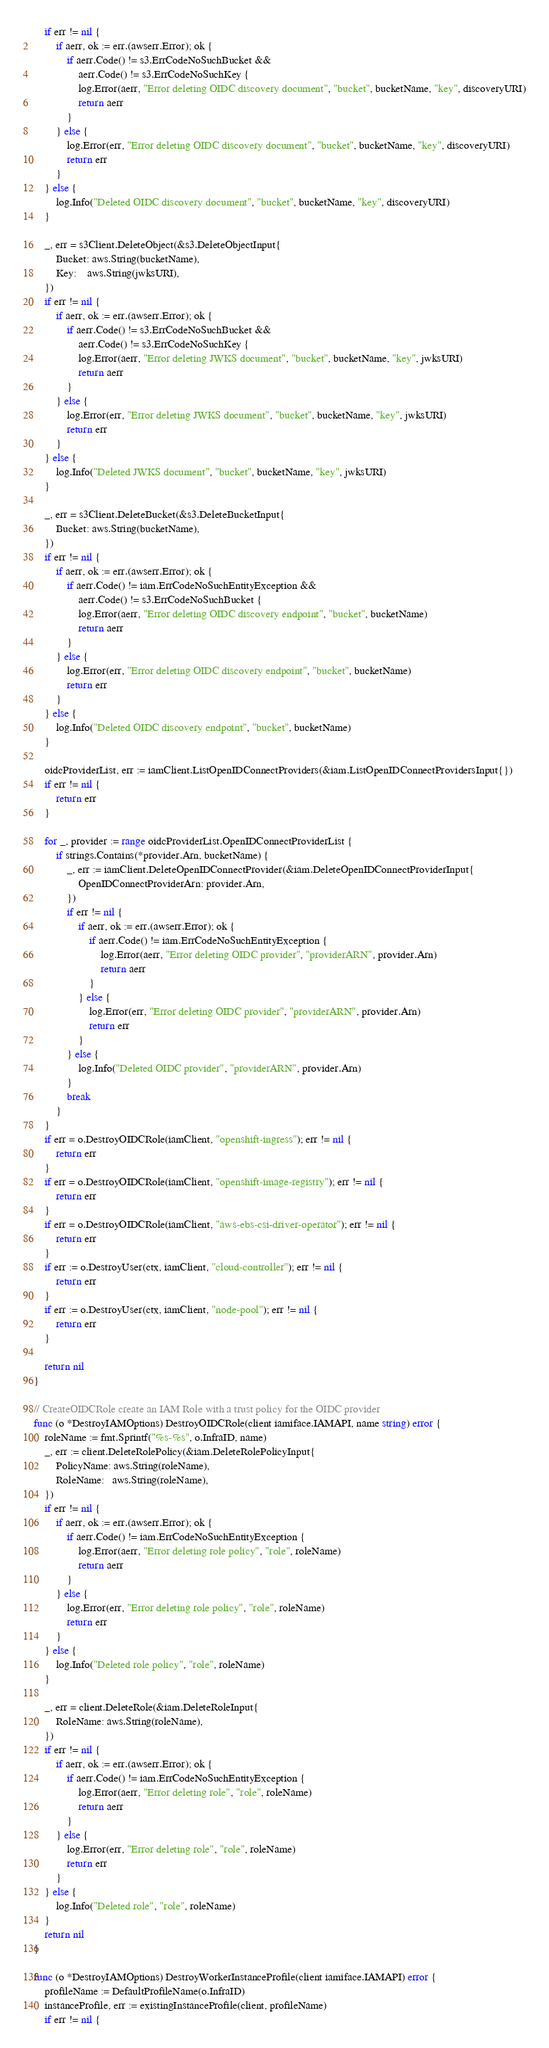Convert code to text. <code><loc_0><loc_0><loc_500><loc_500><_Go_>	if err != nil {
		if aerr, ok := err.(awserr.Error); ok {
			if aerr.Code() != s3.ErrCodeNoSuchBucket &&
				aerr.Code() != s3.ErrCodeNoSuchKey {
				log.Error(aerr, "Error deleting OIDC discovery document", "bucket", bucketName, "key", discoveryURI)
				return aerr
			}
		} else {
			log.Error(err, "Error deleting OIDC discovery document", "bucket", bucketName, "key", discoveryURI)
			return err
		}
	} else {
		log.Info("Deleted OIDC discovery document", "bucket", bucketName, "key", discoveryURI)
	}

	_, err = s3Client.DeleteObject(&s3.DeleteObjectInput{
		Bucket: aws.String(bucketName),
		Key:    aws.String(jwksURI),
	})
	if err != nil {
		if aerr, ok := err.(awserr.Error); ok {
			if aerr.Code() != s3.ErrCodeNoSuchBucket &&
				aerr.Code() != s3.ErrCodeNoSuchKey {
				log.Error(aerr, "Error deleting JWKS document", "bucket", bucketName, "key", jwksURI)
				return aerr
			}
		} else {
			log.Error(err, "Error deleting JWKS document", "bucket", bucketName, "key", jwksURI)
			return err
		}
	} else {
		log.Info("Deleted JWKS document", "bucket", bucketName, "key", jwksURI)
	}

	_, err = s3Client.DeleteBucket(&s3.DeleteBucketInput{
		Bucket: aws.String(bucketName),
	})
	if err != nil {
		if aerr, ok := err.(awserr.Error); ok {
			if aerr.Code() != iam.ErrCodeNoSuchEntityException &&
				aerr.Code() != s3.ErrCodeNoSuchBucket {
				log.Error(aerr, "Error deleting OIDC discovery endpoint", "bucket", bucketName)
				return aerr
			}
		} else {
			log.Error(err, "Error deleting OIDC discovery endpoint", "bucket", bucketName)
			return err
		}
	} else {
		log.Info("Deleted OIDC discovery endpoint", "bucket", bucketName)
	}

	oidcProviderList, err := iamClient.ListOpenIDConnectProviders(&iam.ListOpenIDConnectProvidersInput{})
	if err != nil {
		return err
	}

	for _, provider := range oidcProviderList.OpenIDConnectProviderList {
		if strings.Contains(*provider.Arn, bucketName) {
			_, err := iamClient.DeleteOpenIDConnectProvider(&iam.DeleteOpenIDConnectProviderInput{
				OpenIDConnectProviderArn: provider.Arn,
			})
			if err != nil {
				if aerr, ok := err.(awserr.Error); ok {
					if aerr.Code() != iam.ErrCodeNoSuchEntityException {
						log.Error(aerr, "Error deleting OIDC provider", "providerARN", provider.Arn)
						return aerr
					}
				} else {
					log.Error(err, "Error deleting OIDC provider", "providerARN", provider.Arn)
					return err
				}
			} else {
				log.Info("Deleted OIDC provider", "providerARN", provider.Arn)
			}
			break
		}
	}
	if err = o.DestroyOIDCRole(iamClient, "openshift-ingress"); err != nil {
		return err
	}
	if err = o.DestroyOIDCRole(iamClient, "openshift-image-registry"); err != nil {
		return err
	}
	if err = o.DestroyOIDCRole(iamClient, "aws-ebs-csi-driver-operator"); err != nil {
		return err
	}
	if err := o.DestroyUser(ctx, iamClient, "cloud-controller"); err != nil {
		return err
	}
	if err := o.DestroyUser(ctx, iamClient, "node-pool"); err != nil {
		return err
	}

	return nil
}

// CreateOIDCRole create an IAM Role with a trust policy for the OIDC provider
func (o *DestroyIAMOptions) DestroyOIDCRole(client iamiface.IAMAPI, name string) error {
	roleName := fmt.Sprintf("%s-%s", o.InfraID, name)
	_, err := client.DeleteRolePolicy(&iam.DeleteRolePolicyInput{
		PolicyName: aws.String(roleName),
		RoleName:   aws.String(roleName),
	})
	if err != nil {
		if aerr, ok := err.(awserr.Error); ok {
			if aerr.Code() != iam.ErrCodeNoSuchEntityException {
				log.Error(aerr, "Error deleting role policy", "role", roleName)
				return aerr
			}
		} else {
			log.Error(err, "Error deleting role policy", "role", roleName)
			return err
		}
	} else {
		log.Info("Deleted role policy", "role", roleName)
	}

	_, err = client.DeleteRole(&iam.DeleteRoleInput{
		RoleName: aws.String(roleName),
	})
	if err != nil {
		if aerr, ok := err.(awserr.Error); ok {
			if aerr.Code() != iam.ErrCodeNoSuchEntityException {
				log.Error(aerr, "Error deleting role", "role", roleName)
				return aerr
			}
		} else {
			log.Error(err, "Error deleting role", "role", roleName)
			return err
		}
	} else {
		log.Info("Deleted role", "role", roleName)
	}
	return nil
}

func (o *DestroyIAMOptions) DestroyWorkerInstanceProfile(client iamiface.IAMAPI) error {
	profileName := DefaultProfileName(o.InfraID)
	instanceProfile, err := existingInstanceProfile(client, profileName)
	if err != nil {</code> 